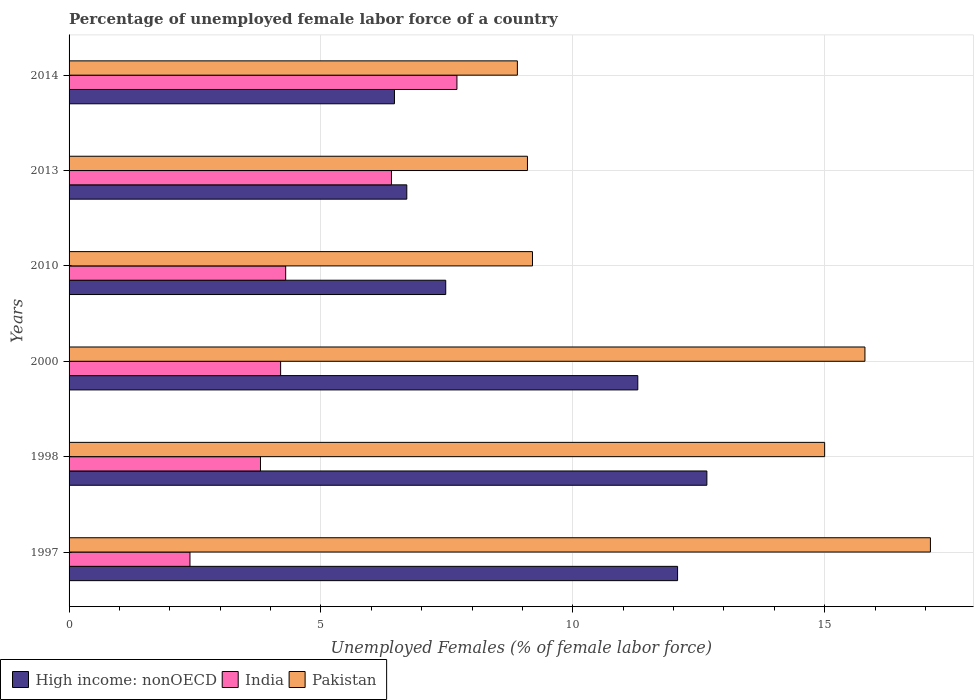How many different coloured bars are there?
Make the answer very short. 3. What is the percentage of unemployed female labor force in India in 2000?
Provide a succinct answer. 4.2. Across all years, what is the maximum percentage of unemployed female labor force in Pakistan?
Your answer should be very brief. 17.1. Across all years, what is the minimum percentage of unemployed female labor force in Pakistan?
Give a very brief answer. 8.9. In which year was the percentage of unemployed female labor force in India maximum?
Offer a very short reply. 2014. What is the total percentage of unemployed female labor force in High income: nonOECD in the graph?
Your answer should be compact. 56.67. What is the difference between the percentage of unemployed female labor force in High income: nonOECD in 2000 and that in 2010?
Ensure brevity in your answer.  3.81. What is the difference between the percentage of unemployed female labor force in High income: nonOECD in 1997 and the percentage of unemployed female labor force in Pakistan in 2013?
Make the answer very short. 2.98. What is the average percentage of unemployed female labor force in India per year?
Give a very brief answer. 4.8. In the year 2010, what is the difference between the percentage of unemployed female labor force in High income: nonOECD and percentage of unemployed female labor force in India?
Make the answer very short. 3.18. What is the ratio of the percentage of unemployed female labor force in Pakistan in 2000 to that in 2010?
Ensure brevity in your answer.  1.72. Is the percentage of unemployed female labor force in High income: nonOECD in 1998 less than that in 2013?
Your answer should be compact. No. Is the difference between the percentage of unemployed female labor force in High income: nonOECD in 2000 and 2014 greater than the difference between the percentage of unemployed female labor force in India in 2000 and 2014?
Offer a terse response. Yes. What is the difference between the highest and the second highest percentage of unemployed female labor force in India?
Your answer should be very brief. 1.3. What is the difference between the highest and the lowest percentage of unemployed female labor force in Pakistan?
Give a very brief answer. 8.2. Is the sum of the percentage of unemployed female labor force in India in 1997 and 2013 greater than the maximum percentage of unemployed female labor force in Pakistan across all years?
Your answer should be compact. No. What does the 3rd bar from the bottom in 2000 represents?
Your response must be concise. Pakistan. Is it the case that in every year, the sum of the percentage of unemployed female labor force in High income: nonOECD and percentage of unemployed female labor force in Pakistan is greater than the percentage of unemployed female labor force in India?
Offer a very short reply. Yes. Are all the bars in the graph horizontal?
Keep it short and to the point. Yes. Are the values on the major ticks of X-axis written in scientific E-notation?
Make the answer very short. No. Does the graph contain any zero values?
Offer a terse response. No. Where does the legend appear in the graph?
Your answer should be very brief. Bottom left. How many legend labels are there?
Keep it short and to the point. 3. How are the legend labels stacked?
Ensure brevity in your answer.  Horizontal. What is the title of the graph?
Ensure brevity in your answer.  Percentage of unemployed female labor force of a country. Does "East Asia (developing only)" appear as one of the legend labels in the graph?
Give a very brief answer. No. What is the label or title of the X-axis?
Provide a succinct answer. Unemployed Females (% of female labor force). What is the label or title of the Y-axis?
Offer a very short reply. Years. What is the Unemployed Females (% of female labor force) in High income: nonOECD in 1997?
Provide a succinct answer. 12.08. What is the Unemployed Females (% of female labor force) in India in 1997?
Ensure brevity in your answer.  2.4. What is the Unemployed Females (% of female labor force) of Pakistan in 1997?
Offer a very short reply. 17.1. What is the Unemployed Females (% of female labor force) in High income: nonOECD in 1998?
Your response must be concise. 12.66. What is the Unemployed Females (% of female labor force) in India in 1998?
Give a very brief answer. 3.8. What is the Unemployed Females (% of female labor force) in High income: nonOECD in 2000?
Ensure brevity in your answer.  11.29. What is the Unemployed Females (% of female labor force) of India in 2000?
Provide a succinct answer. 4.2. What is the Unemployed Females (% of female labor force) in Pakistan in 2000?
Your answer should be very brief. 15.8. What is the Unemployed Females (% of female labor force) of High income: nonOECD in 2010?
Your answer should be compact. 7.48. What is the Unemployed Females (% of female labor force) in India in 2010?
Offer a terse response. 4.3. What is the Unemployed Females (% of female labor force) in Pakistan in 2010?
Make the answer very short. 9.2. What is the Unemployed Females (% of female labor force) in High income: nonOECD in 2013?
Your answer should be very brief. 6.7. What is the Unemployed Females (% of female labor force) in India in 2013?
Your response must be concise. 6.4. What is the Unemployed Females (% of female labor force) in Pakistan in 2013?
Keep it short and to the point. 9.1. What is the Unemployed Females (% of female labor force) of High income: nonOECD in 2014?
Provide a short and direct response. 6.46. What is the Unemployed Females (% of female labor force) of India in 2014?
Give a very brief answer. 7.7. What is the Unemployed Females (% of female labor force) of Pakistan in 2014?
Your response must be concise. 8.9. Across all years, what is the maximum Unemployed Females (% of female labor force) in High income: nonOECD?
Offer a terse response. 12.66. Across all years, what is the maximum Unemployed Females (% of female labor force) of India?
Provide a succinct answer. 7.7. Across all years, what is the maximum Unemployed Females (% of female labor force) in Pakistan?
Make the answer very short. 17.1. Across all years, what is the minimum Unemployed Females (% of female labor force) in High income: nonOECD?
Keep it short and to the point. 6.46. Across all years, what is the minimum Unemployed Females (% of female labor force) in India?
Your answer should be very brief. 2.4. Across all years, what is the minimum Unemployed Females (% of female labor force) in Pakistan?
Offer a very short reply. 8.9. What is the total Unemployed Females (% of female labor force) of High income: nonOECD in the graph?
Provide a short and direct response. 56.67. What is the total Unemployed Females (% of female labor force) in India in the graph?
Make the answer very short. 28.8. What is the total Unemployed Females (% of female labor force) of Pakistan in the graph?
Keep it short and to the point. 75.1. What is the difference between the Unemployed Females (% of female labor force) in High income: nonOECD in 1997 and that in 1998?
Your response must be concise. -0.58. What is the difference between the Unemployed Females (% of female labor force) of India in 1997 and that in 1998?
Keep it short and to the point. -1.4. What is the difference between the Unemployed Females (% of female labor force) of High income: nonOECD in 1997 and that in 2000?
Give a very brief answer. 0.79. What is the difference between the Unemployed Females (% of female labor force) of High income: nonOECD in 1997 and that in 2010?
Provide a succinct answer. 4.6. What is the difference between the Unemployed Females (% of female labor force) in India in 1997 and that in 2010?
Keep it short and to the point. -1.9. What is the difference between the Unemployed Females (% of female labor force) in High income: nonOECD in 1997 and that in 2013?
Make the answer very short. 5.38. What is the difference between the Unemployed Females (% of female labor force) of India in 1997 and that in 2013?
Your answer should be very brief. -4. What is the difference between the Unemployed Females (% of female labor force) of Pakistan in 1997 and that in 2013?
Ensure brevity in your answer.  8. What is the difference between the Unemployed Females (% of female labor force) in High income: nonOECD in 1997 and that in 2014?
Offer a very short reply. 5.62. What is the difference between the Unemployed Females (% of female labor force) of India in 1997 and that in 2014?
Provide a short and direct response. -5.3. What is the difference between the Unemployed Females (% of female labor force) in Pakistan in 1997 and that in 2014?
Provide a succinct answer. 8.2. What is the difference between the Unemployed Females (% of female labor force) of High income: nonOECD in 1998 and that in 2000?
Your response must be concise. 1.37. What is the difference between the Unemployed Females (% of female labor force) in India in 1998 and that in 2000?
Your response must be concise. -0.4. What is the difference between the Unemployed Females (% of female labor force) in Pakistan in 1998 and that in 2000?
Your answer should be very brief. -0.8. What is the difference between the Unemployed Females (% of female labor force) in High income: nonOECD in 1998 and that in 2010?
Keep it short and to the point. 5.18. What is the difference between the Unemployed Females (% of female labor force) of Pakistan in 1998 and that in 2010?
Your answer should be compact. 5.8. What is the difference between the Unemployed Females (% of female labor force) of High income: nonOECD in 1998 and that in 2013?
Make the answer very short. 5.96. What is the difference between the Unemployed Females (% of female labor force) of India in 1998 and that in 2013?
Provide a short and direct response. -2.6. What is the difference between the Unemployed Females (% of female labor force) in High income: nonOECD in 1998 and that in 2014?
Offer a very short reply. 6.2. What is the difference between the Unemployed Females (% of female labor force) in India in 1998 and that in 2014?
Provide a succinct answer. -3.9. What is the difference between the Unemployed Females (% of female labor force) of High income: nonOECD in 2000 and that in 2010?
Your response must be concise. 3.81. What is the difference between the Unemployed Females (% of female labor force) in Pakistan in 2000 and that in 2010?
Offer a very short reply. 6.6. What is the difference between the Unemployed Females (% of female labor force) of High income: nonOECD in 2000 and that in 2013?
Provide a short and direct response. 4.59. What is the difference between the Unemployed Females (% of female labor force) in Pakistan in 2000 and that in 2013?
Make the answer very short. 6.7. What is the difference between the Unemployed Females (% of female labor force) of High income: nonOECD in 2000 and that in 2014?
Your answer should be very brief. 4.83. What is the difference between the Unemployed Females (% of female labor force) in India in 2000 and that in 2014?
Your response must be concise. -3.5. What is the difference between the Unemployed Females (% of female labor force) in Pakistan in 2000 and that in 2014?
Make the answer very short. 6.9. What is the difference between the Unemployed Females (% of female labor force) in High income: nonOECD in 2010 and that in 2013?
Make the answer very short. 0.77. What is the difference between the Unemployed Females (% of female labor force) in Pakistan in 2010 and that in 2014?
Provide a succinct answer. 0.3. What is the difference between the Unemployed Females (% of female labor force) of High income: nonOECD in 2013 and that in 2014?
Your response must be concise. 0.24. What is the difference between the Unemployed Females (% of female labor force) in Pakistan in 2013 and that in 2014?
Your response must be concise. 0.2. What is the difference between the Unemployed Females (% of female labor force) in High income: nonOECD in 1997 and the Unemployed Females (% of female labor force) in India in 1998?
Your answer should be compact. 8.28. What is the difference between the Unemployed Females (% of female labor force) of High income: nonOECD in 1997 and the Unemployed Females (% of female labor force) of Pakistan in 1998?
Your answer should be very brief. -2.92. What is the difference between the Unemployed Females (% of female labor force) of High income: nonOECD in 1997 and the Unemployed Females (% of female labor force) of India in 2000?
Ensure brevity in your answer.  7.88. What is the difference between the Unemployed Females (% of female labor force) of High income: nonOECD in 1997 and the Unemployed Females (% of female labor force) of Pakistan in 2000?
Provide a succinct answer. -3.72. What is the difference between the Unemployed Females (% of female labor force) of India in 1997 and the Unemployed Females (% of female labor force) of Pakistan in 2000?
Ensure brevity in your answer.  -13.4. What is the difference between the Unemployed Females (% of female labor force) in High income: nonOECD in 1997 and the Unemployed Females (% of female labor force) in India in 2010?
Offer a terse response. 7.78. What is the difference between the Unemployed Females (% of female labor force) in High income: nonOECD in 1997 and the Unemployed Females (% of female labor force) in Pakistan in 2010?
Make the answer very short. 2.88. What is the difference between the Unemployed Females (% of female labor force) in High income: nonOECD in 1997 and the Unemployed Females (% of female labor force) in India in 2013?
Your response must be concise. 5.68. What is the difference between the Unemployed Females (% of female labor force) of High income: nonOECD in 1997 and the Unemployed Females (% of female labor force) of Pakistan in 2013?
Offer a very short reply. 2.98. What is the difference between the Unemployed Females (% of female labor force) in India in 1997 and the Unemployed Females (% of female labor force) in Pakistan in 2013?
Make the answer very short. -6.7. What is the difference between the Unemployed Females (% of female labor force) of High income: nonOECD in 1997 and the Unemployed Females (% of female labor force) of India in 2014?
Your answer should be very brief. 4.38. What is the difference between the Unemployed Females (% of female labor force) in High income: nonOECD in 1997 and the Unemployed Females (% of female labor force) in Pakistan in 2014?
Offer a terse response. 3.18. What is the difference between the Unemployed Females (% of female labor force) of India in 1997 and the Unemployed Females (% of female labor force) of Pakistan in 2014?
Your answer should be very brief. -6.5. What is the difference between the Unemployed Females (% of female labor force) in High income: nonOECD in 1998 and the Unemployed Females (% of female labor force) in India in 2000?
Provide a succinct answer. 8.46. What is the difference between the Unemployed Females (% of female labor force) in High income: nonOECD in 1998 and the Unemployed Females (% of female labor force) in Pakistan in 2000?
Keep it short and to the point. -3.14. What is the difference between the Unemployed Females (% of female labor force) in India in 1998 and the Unemployed Females (% of female labor force) in Pakistan in 2000?
Your response must be concise. -12. What is the difference between the Unemployed Females (% of female labor force) in High income: nonOECD in 1998 and the Unemployed Females (% of female labor force) in India in 2010?
Give a very brief answer. 8.36. What is the difference between the Unemployed Females (% of female labor force) of High income: nonOECD in 1998 and the Unemployed Females (% of female labor force) of Pakistan in 2010?
Ensure brevity in your answer.  3.46. What is the difference between the Unemployed Females (% of female labor force) in India in 1998 and the Unemployed Females (% of female labor force) in Pakistan in 2010?
Give a very brief answer. -5.4. What is the difference between the Unemployed Females (% of female labor force) in High income: nonOECD in 1998 and the Unemployed Females (% of female labor force) in India in 2013?
Offer a terse response. 6.26. What is the difference between the Unemployed Females (% of female labor force) of High income: nonOECD in 1998 and the Unemployed Females (% of female labor force) of Pakistan in 2013?
Your answer should be very brief. 3.56. What is the difference between the Unemployed Females (% of female labor force) in India in 1998 and the Unemployed Females (% of female labor force) in Pakistan in 2013?
Offer a terse response. -5.3. What is the difference between the Unemployed Females (% of female labor force) in High income: nonOECD in 1998 and the Unemployed Females (% of female labor force) in India in 2014?
Ensure brevity in your answer.  4.96. What is the difference between the Unemployed Females (% of female labor force) of High income: nonOECD in 1998 and the Unemployed Females (% of female labor force) of Pakistan in 2014?
Offer a terse response. 3.76. What is the difference between the Unemployed Females (% of female labor force) in India in 1998 and the Unemployed Females (% of female labor force) in Pakistan in 2014?
Keep it short and to the point. -5.1. What is the difference between the Unemployed Females (% of female labor force) in High income: nonOECD in 2000 and the Unemployed Females (% of female labor force) in India in 2010?
Your answer should be very brief. 6.99. What is the difference between the Unemployed Females (% of female labor force) in High income: nonOECD in 2000 and the Unemployed Females (% of female labor force) in Pakistan in 2010?
Offer a very short reply. 2.09. What is the difference between the Unemployed Females (% of female labor force) in High income: nonOECD in 2000 and the Unemployed Females (% of female labor force) in India in 2013?
Make the answer very short. 4.89. What is the difference between the Unemployed Females (% of female labor force) of High income: nonOECD in 2000 and the Unemployed Females (% of female labor force) of Pakistan in 2013?
Your answer should be compact. 2.19. What is the difference between the Unemployed Females (% of female labor force) in India in 2000 and the Unemployed Females (% of female labor force) in Pakistan in 2013?
Offer a terse response. -4.9. What is the difference between the Unemployed Females (% of female labor force) of High income: nonOECD in 2000 and the Unemployed Females (% of female labor force) of India in 2014?
Make the answer very short. 3.59. What is the difference between the Unemployed Females (% of female labor force) in High income: nonOECD in 2000 and the Unemployed Females (% of female labor force) in Pakistan in 2014?
Ensure brevity in your answer.  2.39. What is the difference between the Unemployed Females (% of female labor force) in High income: nonOECD in 2010 and the Unemployed Females (% of female labor force) in India in 2013?
Ensure brevity in your answer.  1.08. What is the difference between the Unemployed Females (% of female labor force) in High income: nonOECD in 2010 and the Unemployed Females (% of female labor force) in Pakistan in 2013?
Offer a very short reply. -1.62. What is the difference between the Unemployed Females (% of female labor force) in India in 2010 and the Unemployed Females (% of female labor force) in Pakistan in 2013?
Ensure brevity in your answer.  -4.8. What is the difference between the Unemployed Females (% of female labor force) in High income: nonOECD in 2010 and the Unemployed Females (% of female labor force) in India in 2014?
Offer a terse response. -0.22. What is the difference between the Unemployed Females (% of female labor force) in High income: nonOECD in 2010 and the Unemployed Females (% of female labor force) in Pakistan in 2014?
Your response must be concise. -1.42. What is the difference between the Unemployed Females (% of female labor force) in High income: nonOECD in 2013 and the Unemployed Females (% of female labor force) in India in 2014?
Ensure brevity in your answer.  -1. What is the difference between the Unemployed Females (% of female labor force) in High income: nonOECD in 2013 and the Unemployed Females (% of female labor force) in Pakistan in 2014?
Provide a succinct answer. -2.2. What is the difference between the Unemployed Females (% of female labor force) in India in 2013 and the Unemployed Females (% of female labor force) in Pakistan in 2014?
Your response must be concise. -2.5. What is the average Unemployed Females (% of female labor force) of High income: nonOECD per year?
Offer a terse response. 9.45. What is the average Unemployed Females (% of female labor force) in Pakistan per year?
Your answer should be very brief. 12.52. In the year 1997, what is the difference between the Unemployed Females (% of female labor force) in High income: nonOECD and Unemployed Females (% of female labor force) in India?
Your answer should be compact. 9.68. In the year 1997, what is the difference between the Unemployed Females (% of female labor force) in High income: nonOECD and Unemployed Females (% of female labor force) in Pakistan?
Keep it short and to the point. -5.02. In the year 1997, what is the difference between the Unemployed Females (% of female labor force) in India and Unemployed Females (% of female labor force) in Pakistan?
Your answer should be compact. -14.7. In the year 1998, what is the difference between the Unemployed Females (% of female labor force) in High income: nonOECD and Unemployed Females (% of female labor force) in India?
Give a very brief answer. 8.86. In the year 1998, what is the difference between the Unemployed Females (% of female labor force) in High income: nonOECD and Unemployed Females (% of female labor force) in Pakistan?
Offer a very short reply. -2.34. In the year 2000, what is the difference between the Unemployed Females (% of female labor force) in High income: nonOECD and Unemployed Females (% of female labor force) in India?
Offer a terse response. 7.09. In the year 2000, what is the difference between the Unemployed Females (% of female labor force) of High income: nonOECD and Unemployed Females (% of female labor force) of Pakistan?
Provide a short and direct response. -4.51. In the year 2010, what is the difference between the Unemployed Females (% of female labor force) of High income: nonOECD and Unemployed Females (% of female labor force) of India?
Offer a very short reply. 3.18. In the year 2010, what is the difference between the Unemployed Females (% of female labor force) in High income: nonOECD and Unemployed Females (% of female labor force) in Pakistan?
Offer a terse response. -1.72. In the year 2013, what is the difference between the Unemployed Females (% of female labor force) in High income: nonOECD and Unemployed Females (% of female labor force) in India?
Your response must be concise. 0.3. In the year 2013, what is the difference between the Unemployed Females (% of female labor force) in High income: nonOECD and Unemployed Females (% of female labor force) in Pakistan?
Offer a terse response. -2.4. In the year 2013, what is the difference between the Unemployed Females (% of female labor force) in India and Unemployed Females (% of female labor force) in Pakistan?
Ensure brevity in your answer.  -2.7. In the year 2014, what is the difference between the Unemployed Females (% of female labor force) of High income: nonOECD and Unemployed Females (% of female labor force) of India?
Offer a very short reply. -1.24. In the year 2014, what is the difference between the Unemployed Females (% of female labor force) of High income: nonOECD and Unemployed Females (% of female labor force) of Pakistan?
Ensure brevity in your answer.  -2.44. In the year 2014, what is the difference between the Unemployed Females (% of female labor force) of India and Unemployed Females (% of female labor force) of Pakistan?
Your answer should be very brief. -1.2. What is the ratio of the Unemployed Females (% of female labor force) in High income: nonOECD in 1997 to that in 1998?
Make the answer very short. 0.95. What is the ratio of the Unemployed Females (% of female labor force) in India in 1997 to that in 1998?
Provide a succinct answer. 0.63. What is the ratio of the Unemployed Females (% of female labor force) of Pakistan in 1997 to that in 1998?
Your answer should be compact. 1.14. What is the ratio of the Unemployed Females (% of female labor force) in High income: nonOECD in 1997 to that in 2000?
Provide a short and direct response. 1.07. What is the ratio of the Unemployed Females (% of female labor force) of India in 1997 to that in 2000?
Ensure brevity in your answer.  0.57. What is the ratio of the Unemployed Females (% of female labor force) of Pakistan in 1997 to that in 2000?
Keep it short and to the point. 1.08. What is the ratio of the Unemployed Females (% of female labor force) of High income: nonOECD in 1997 to that in 2010?
Give a very brief answer. 1.62. What is the ratio of the Unemployed Females (% of female labor force) in India in 1997 to that in 2010?
Your answer should be compact. 0.56. What is the ratio of the Unemployed Females (% of female labor force) of Pakistan in 1997 to that in 2010?
Ensure brevity in your answer.  1.86. What is the ratio of the Unemployed Females (% of female labor force) in High income: nonOECD in 1997 to that in 2013?
Offer a very short reply. 1.8. What is the ratio of the Unemployed Females (% of female labor force) of Pakistan in 1997 to that in 2013?
Ensure brevity in your answer.  1.88. What is the ratio of the Unemployed Females (% of female labor force) in High income: nonOECD in 1997 to that in 2014?
Your response must be concise. 1.87. What is the ratio of the Unemployed Females (% of female labor force) in India in 1997 to that in 2014?
Your response must be concise. 0.31. What is the ratio of the Unemployed Females (% of female labor force) of Pakistan in 1997 to that in 2014?
Keep it short and to the point. 1.92. What is the ratio of the Unemployed Females (% of female labor force) of High income: nonOECD in 1998 to that in 2000?
Give a very brief answer. 1.12. What is the ratio of the Unemployed Females (% of female labor force) in India in 1998 to that in 2000?
Provide a succinct answer. 0.9. What is the ratio of the Unemployed Females (% of female labor force) in Pakistan in 1998 to that in 2000?
Provide a succinct answer. 0.95. What is the ratio of the Unemployed Females (% of female labor force) in High income: nonOECD in 1998 to that in 2010?
Ensure brevity in your answer.  1.69. What is the ratio of the Unemployed Females (% of female labor force) in India in 1998 to that in 2010?
Your answer should be compact. 0.88. What is the ratio of the Unemployed Females (% of female labor force) in Pakistan in 1998 to that in 2010?
Keep it short and to the point. 1.63. What is the ratio of the Unemployed Females (% of female labor force) of High income: nonOECD in 1998 to that in 2013?
Offer a very short reply. 1.89. What is the ratio of the Unemployed Females (% of female labor force) of India in 1998 to that in 2013?
Offer a very short reply. 0.59. What is the ratio of the Unemployed Females (% of female labor force) of Pakistan in 1998 to that in 2013?
Provide a short and direct response. 1.65. What is the ratio of the Unemployed Females (% of female labor force) of High income: nonOECD in 1998 to that in 2014?
Your answer should be very brief. 1.96. What is the ratio of the Unemployed Females (% of female labor force) in India in 1998 to that in 2014?
Your response must be concise. 0.49. What is the ratio of the Unemployed Females (% of female labor force) of Pakistan in 1998 to that in 2014?
Your answer should be compact. 1.69. What is the ratio of the Unemployed Females (% of female labor force) of High income: nonOECD in 2000 to that in 2010?
Offer a very short reply. 1.51. What is the ratio of the Unemployed Females (% of female labor force) of India in 2000 to that in 2010?
Make the answer very short. 0.98. What is the ratio of the Unemployed Females (% of female labor force) in Pakistan in 2000 to that in 2010?
Keep it short and to the point. 1.72. What is the ratio of the Unemployed Females (% of female labor force) in High income: nonOECD in 2000 to that in 2013?
Ensure brevity in your answer.  1.68. What is the ratio of the Unemployed Females (% of female labor force) in India in 2000 to that in 2013?
Offer a very short reply. 0.66. What is the ratio of the Unemployed Females (% of female labor force) in Pakistan in 2000 to that in 2013?
Your answer should be compact. 1.74. What is the ratio of the Unemployed Females (% of female labor force) in High income: nonOECD in 2000 to that in 2014?
Offer a terse response. 1.75. What is the ratio of the Unemployed Females (% of female labor force) in India in 2000 to that in 2014?
Your answer should be very brief. 0.55. What is the ratio of the Unemployed Females (% of female labor force) of Pakistan in 2000 to that in 2014?
Offer a very short reply. 1.78. What is the ratio of the Unemployed Females (% of female labor force) in High income: nonOECD in 2010 to that in 2013?
Ensure brevity in your answer.  1.12. What is the ratio of the Unemployed Females (% of female labor force) of India in 2010 to that in 2013?
Your answer should be very brief. 0.67. What is the ratio of the Unemployed Females (% of female labor force) of Pakistan in 2010 to that in 2013?
Provide a succinct answer. 1.01. What is the ratio of the Unemployed Females (% of female labor force) in High income: nonOECD in 2010 to that in 2014?
Offer a very short reply. 1.16. What is the ratio of the Unemployed Females (% of female labor force) in India in 2010 to that in 2014?
Offer a very short reply. 0.56. What is the ratio of the Unemployed Females (% of female labor force) of Pakistan in 2010 to that in 2014?
Give a very brief answer. 1.03. What is the ratio of the Unemployed Females (% of female labor force) in High income: nonOECD in 2013 to that in 2014?
Offer a terse response. 1.04. What is the ratio of the Unemployed Females (% of female labor force) in India in 2013 to that in 2014?
Offer a terse response. 0.83. What is the ratio of the Unemployed Females (% of female labor force) of Pakistan in 2013 to that in 2014?
Offer a very short reply. 1.02. What is the difference between the highest and the second highest Unemployed Females (% of female labor force) of High income: nonOECD?
Ensure brevity in your answer.  0.58. What is the difference between the highest and the second highest Unemployed Females (% of female labor force) in India?
Offer a very short reply. 1.3. What is the difference between the highest and the second highest Unemployed Females (% of female labor force) of Pakistan?
Ensure brevity in your answer.  1.3. What is the difference between the highest and the lowest Unemployed Females (% of female labor force) of High income: nonOECD?
Offer a very short reply. 6.2. What is the difference between the highest and the lowest Unemployed Females (% of female labor force) of India?
Keep it short and to the point. 5.3. 